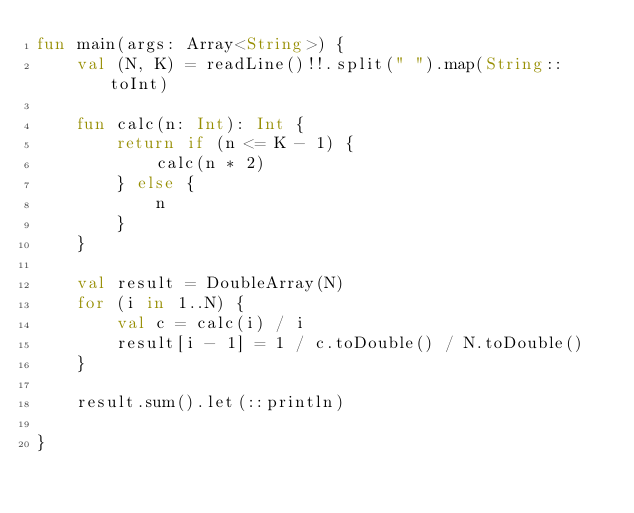<code> <loc_0><loc_0><loc_500><loc_500><_Kotlin_>fun main(args: Array<String>) {
    val (N, K) = readLine()!!.split(" ").map(String::toInt)

    fun calc(n: Int): Int {
        return if (n <= K - 1) {
            calc(n * 2)
        } else {
            n
        }
    }

    val result = DoubleArray(N)
    for (i in 1..N) {
        val c = calc(i) / i
        result[i - 1] = 1 / c.toDouble() / N.toDouble()
    }

    result.sum().let(::println)

}</code> 